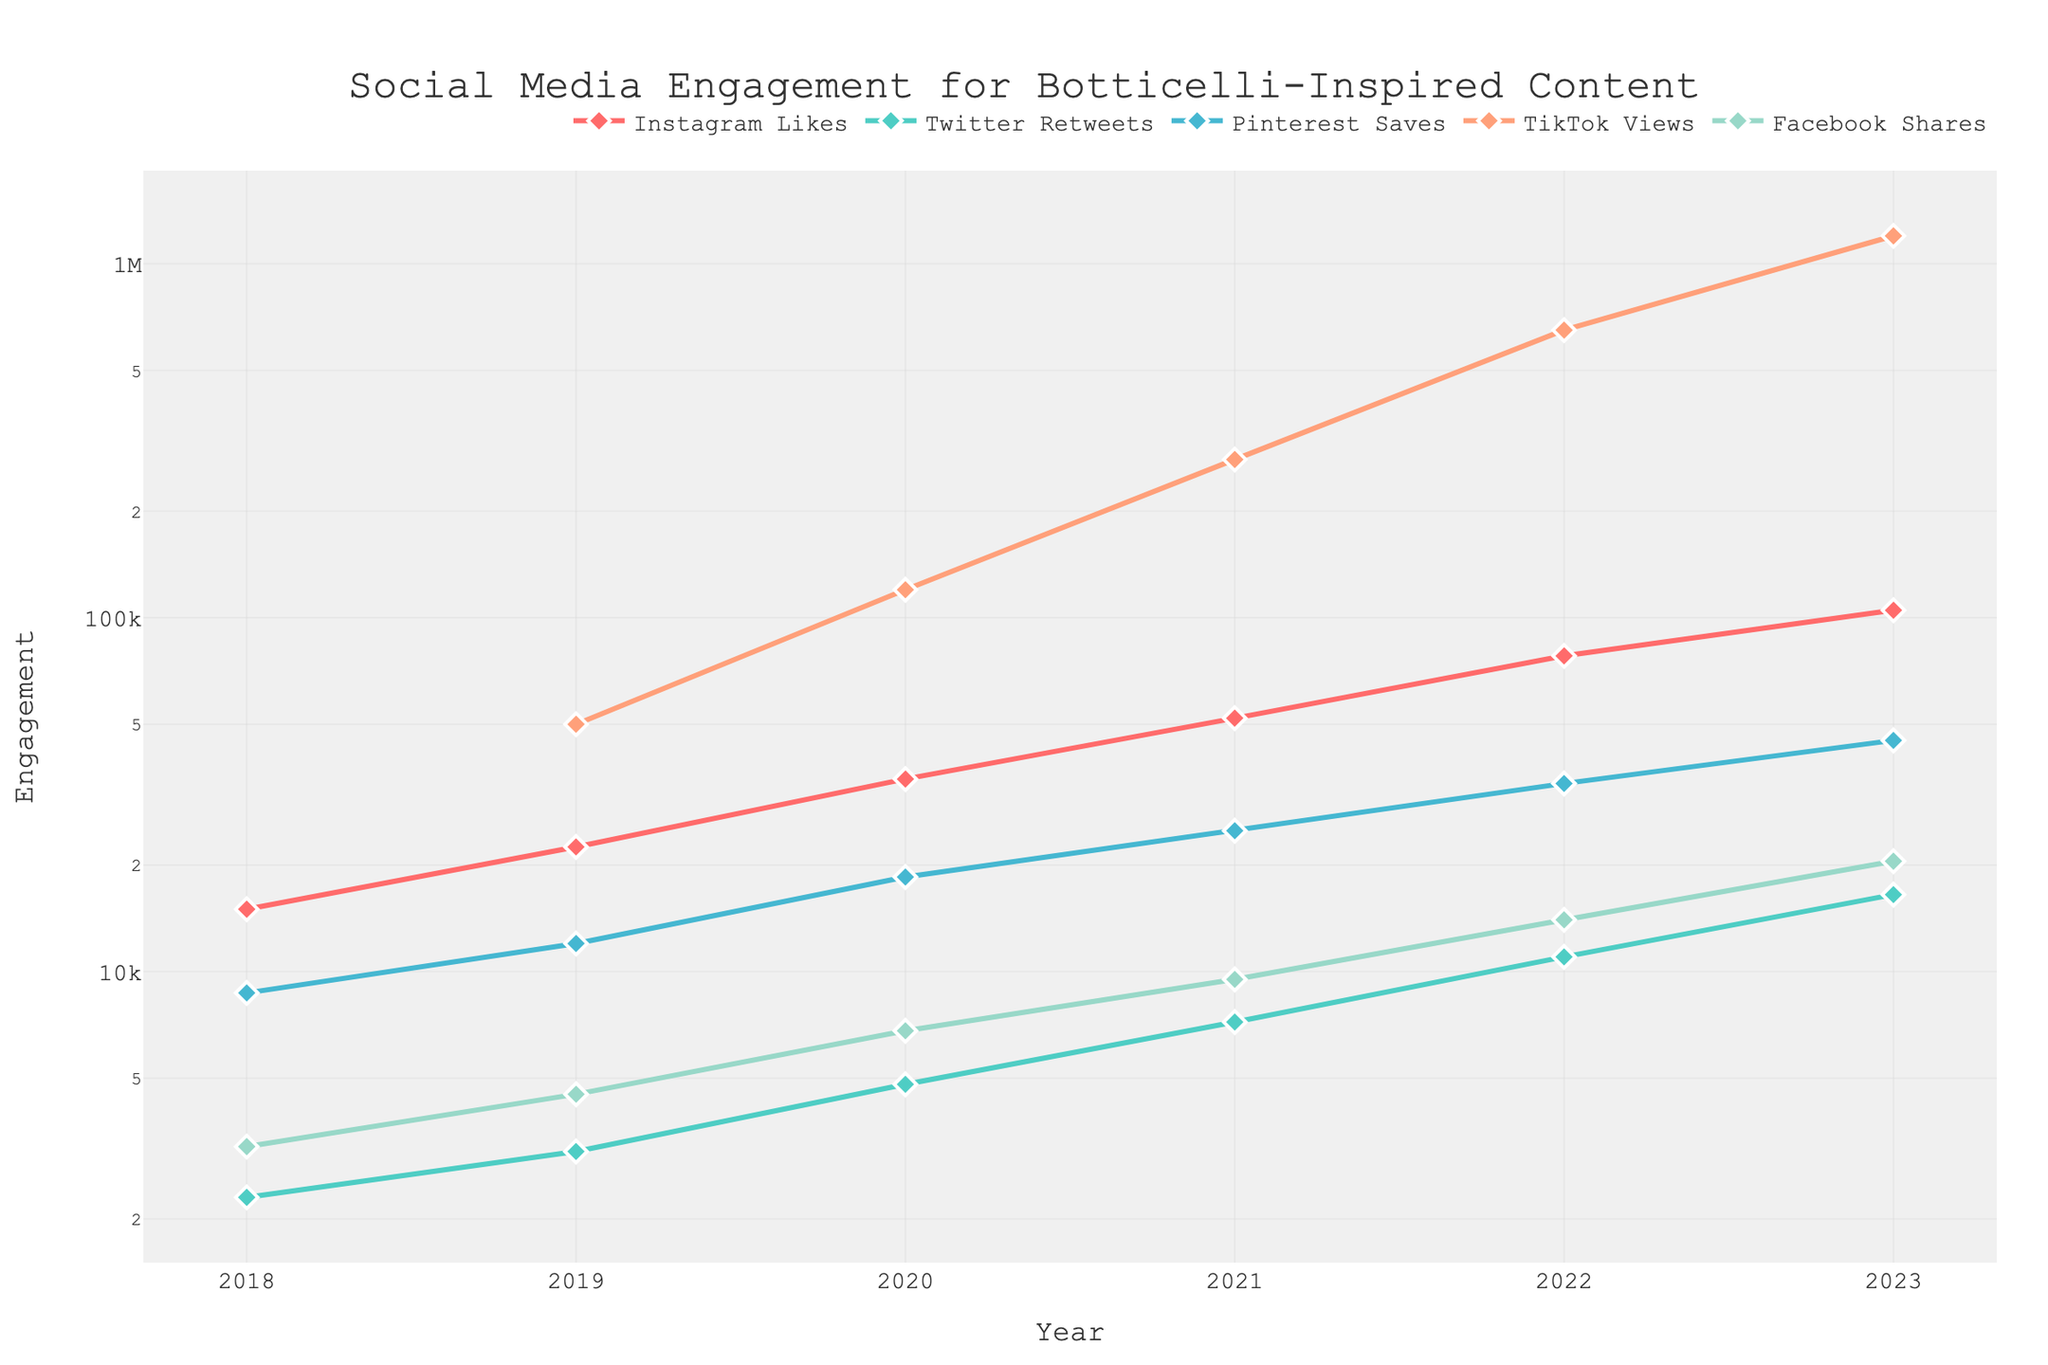What is the trend of Instagram Likes from 2018 to 2023? By examining the line associated with Instagram Likes, it's clear that each year the number of likes increased. The values rose from 15,000 in 2018 to 105,000 in 2023, indicating a positive trend.
Answer: Increasing Which platform saw the highest engagement in 2023? By looking at the highest point on the y-axis for the year 2023, TikTok Views have the highest value at 1,200,000 compared with other platforms.
Answer: TikTok Views How do Pinterest Saves in 2020 compare to Facebook Shares in the same year? Pinterest Saves in 2020 were 18,500 while Facebook Shares were 6,800. Therefore, Pinterest Saves were greater than Facebook Shares in 2020.
Answer: Pinterest Saves were higher What is the total number of Twitter Retweets from 2018 to 2023? Summing the values for Twitter Retweets for each year (2300 + 3100 + 4800 + 7200 + 11000 + 16500), the total is 44,900.
Answer: 44,900 Which two platforms exhibited increasing engagement in every single year from 2018 to 2023? By observing the lines, both TikTok Views and Instagram Likes have continuously upward trends without any decrease in values year over year.
Answer: TikTok Views and Instagram Likes In what year did Facebook Shares surpass Instagram Likes for the first time? Facebook Shares never surpassed Instagram Likes. By the data from 2018 to 2023, Instagram Likes were consistently higher each year.
Answer: Never What was the difference between the highest and lowest TikTok Views? The highest TikTok Views were 1,200,000 in 2023, and since TikTok Views were introduced in 2019 with 50,000 views, the difference is 1,200,000 - 50,000 = 1,150,000.
Answer: 1,150,000 Which year saw the greatest increase in Twitter Retweets as compared to the previous year? By checking the differences between consecutive years: 2019-2018 (3100-2300=800), 2020-2019 (4800-3100=1700), 2021-2020 (7200-4800=2400), 2022-2021 (11000-7200=3800), 2023-2022 (16500-11000=5500). The largest increase was from 2022 to 2023 by 5,500 Retweets.
Answer: 2022 to 2023 Compare the trends of Pinterest Saves and TikTok Views from 2019 to 2023. Pinterest Saves increased steadily from 12,000 in 2019 to 45,000 in 2023. In contrast, TikTok Views showed a more significant increase from 50,000 in 2019 to 1,200,000 in 2023, with especially sharp rises in 2021 and 2023.
Answer: Pinterest Saves increased steadily, while TikTok Views increased sharply 